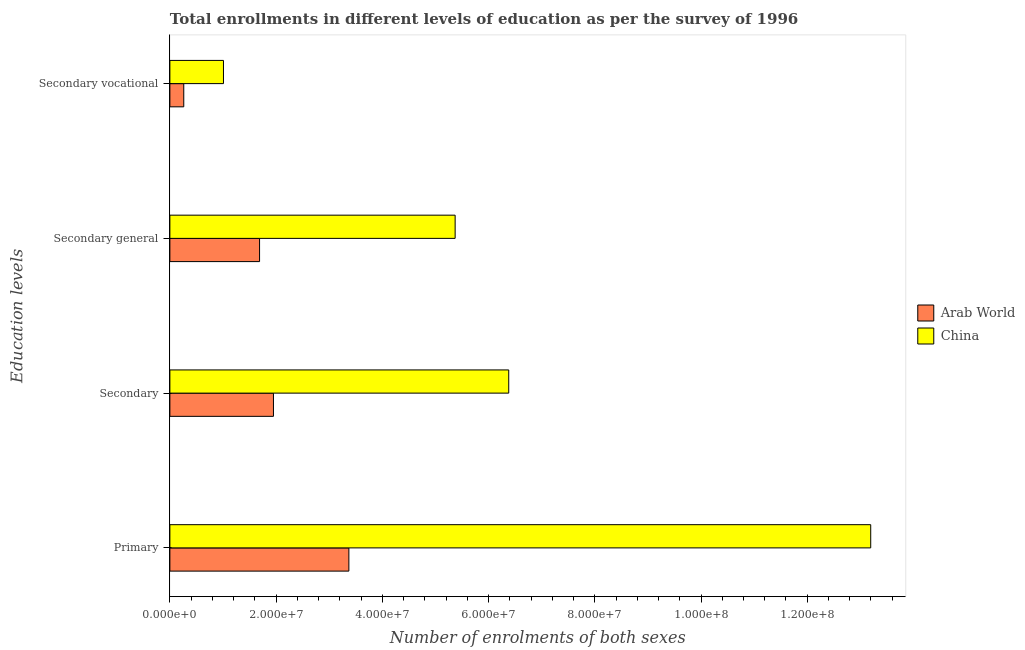Are the number of bars per tick equal to the number of legend labels?
Ensure brevity in your answer.  Yes. How many bars are there on the 4th tick from the bottom?
Your answer should be very brief. 2. What is the label of the 3rd group of bars from the top?
Your answer should be compact. Secondary. What is the number of enrolments in secondary general education in China?
Give a very brief answer. 5.37e+07. Across all countries, what is the maximum number of enrolments in primary education?
Provide a succinct answer. 1.32e+08. Across all countries, what is the minimum number of enrolments in primary education?
Give a very brief answer. 3.37e+07. In which country was the number of enrolments in secondary vocational education minimum?
Your response must be concise. Arab World. What is the total number of enrolments in secondary general education in the graph?
Your answer should be very brief. 7.06e+07. What is the difference between the number of enrolments in secondary general education in China and that in Arab World?
Offer a very short reply. 3.68e+07. What is the difference between the number of enrolments in primary education in China and the number of enrolments in secondary general education in Arab World?
Offer a very short reply. 1.15e+08. What is the average number of enrolments in secondary vocational education per country?
Make the answer very short. 6.35e+06. What is the difference between the number of enrolments in secondary general education and number of enrolments in primary education in Arab World?
Give a very brief answer. -1.68e+07. In how many countries, is the number of enrolments in secondary education greater than 32000000 ?
Your answer should be very brief. 1. What is the ratio of the number of enrolments in secondary vocational education in Arab World to that in China?
Give a very brief answer. 0.26. Is the number of enrolments in secondary education in China less than that in Arab World?
Offer a very short reply. No. What is the difference between the highest and the second highest number of enrolments in secondary vocational education?
Your answer should be very brief. 7.48e+06. What is the difference between the highest and the lowest number of enrolments in secondary general education?
Give a very brief answer. 3.68e+07. What does the 1st bar from the top in Secondary general represents?
Offer a terse response. China. Is it the case that in every country, the sum of the number of enrolments in primary education and number of enrolments in secondary education is greater than the number of enrolments in secondary general education?
Offer a very short reply. Yes. How many bars are there?
Provide a short and direct response. 8. How many countries are there in the graph?
Your response must be concise. 2. Does the graph contain grids?
Offer a very short reply. No. Where does the legend appear in the graph?
Provide a succinct answer. Center right. What is the title of the graph?
Your response must be concise. Total enrollments in different levels of education as per the survey of 1996. What is the label or title of the X-axis?
Keep it short and to the point. Number of enrolments of both sexes. What is the label or title of the Y-axis?
Give a very brief answer. Education levels. What is the Number of enrolments of both sexes of Arab World in Primary?
Provide a short and direct response. 3.37e+07. What is the Number of enrolments of both sexes of China in Primary?
Your answer should be compact. 1.32e+08. What is the Number of enrolments of both sexes in Arab World in Secondary?
Your response must be concise. 1.95e+07. What is the Number of enrolments of both sexes of China in Secondary?
Give a very brief answer. 6.38e+07. What is the Number of enrolments of both sexes in Arab World in Secondary general?
Provide a short and direct response. 1.69e+07. What is the Number of enrolments of both sexes of China in Secondary general?
Your answer should be very brief. 5.37e+07. What is the Number of enrolments of both sexes in Arab World in Secondary vocational?
Your response must be concise. 2.61e+06. What is the Number of enrolments of both sexes in China in Secondary vocational?
Keep it short and to the point. 1.01e+07. Across all Education levels, what is the maximum Number of enrolments of both sexes in Arab World?
Ensure brevity in your answer.  3.37e+07. Across all Education levels, what is the maximum Number of enrolments of both sexes of China?
Make the answer very short. 1.32e+08. Across all Education levels, what is the minimum Number of enrolments of both sexes of Arab World?
Your answer should be very brief. 2.61e+06. Across all Education levels, what is the minimum Number of enrolments of both sexes of China?
Keep it short and to the point. 1.01e+07. What is the total Number of enrolments of both sexes of Arab World in the graph?
Keep it short and to the point. 7.27e+07. What is the total Number of enrolments of both sexes in China in the graph?
Your response must be concise. 2.60e+08. What is the difference between the Number of enrolments of both sexes in Arab World in Primary and that in Secondary?
Give a very brief answer. 1.42e+07. What is the difference between the Number of enrolments of both sexes in China in Primary and that in Secondary?
Your answer should be compact. 6.82e+07. What is the difference between the Number of enrolments of both sexes in Arab World in Primary and that in Secondary general?
Offer a terse response. 1.68e+07. What is the difference between the Number of enrolments of both sexes of China in Primary and that in Secondary general?
Keep it short and to the point. 7.82e+07. What is the difference between the Number of enrolments of both sexes of Arab World in Primary and that in Secondary vocational?
Your response must be concise. 3.11e+07. What is the difference between the Number of enrolments of both sexes in China in Primary and that in Secondary vocational?
Your answer should be compact. 1.22e+08. What is the difference between the Number of enrolments of both sexes in Arab World in Secondary and that in Secondary general?
Your answer should be very brief. 2.61e+06. What is the difference between the Number of enrolments of both sexes in China in Secondary and that in Secondary general?
Give a very brief answer. 1.01e+07. What is the difference between the Number of enrolments of both sexes in Arab World in Secondary and that in Secondary vocational?
Your response must be concise. 1.69e+07. What is the difference between the Number of enrolments of both sexes of China in Secondary and that in Secondary vocational?
Your answer should be compact. 5.37e+07. What is the difference between the Number of enrolments of both sexes of Arab World in Secondary general and that in Secondary vocational?
Offer a very short reply. 1.43e+07. What is the difference between the Number of enrolments of both sexes in China in Secondary general and that in Secondary vocational?
Keep it short and to the point. 4.36e+07. What is the difference between the Number of enrolments of both sexes in Arab World in Primary and the Number of enrolments of both sexes in China in Secondary?
Provide a succinct answer. -3.01e+07. What is the difference between the Number of enrolments of both sexes of Arab World in Primary and the Number of enrolments of both sexes of China in Secondary general?
Provide a short and direct response. -2.00e+07. What is the difference between the Number of enrolments of both sexes in Arab World in Primary and the Number of enrolments of both sexes in China in Secondary vocational?
Your response must be concise. 2.36e+07. What is the difference between the Number of enrolments of both sexes in Arab World in Secondary and the Number of enrolments of both sexes in China in Secondary general?
Offer a very short reply. -3.42e+07. What is the difference between the Number of enrolments of both sexes of Arab World in Secondary and the Number of enrolments of both sexes of China in Secondary vocational?
Make the answer very short. 9.41e+06. What is the difference between the Number of enrolments of both sexes in Arab World in Secondary general and the Number of enrolments of both sexes in China in Secondary vocational?
Offer a very short reply. 6.80e+06. What is the average Number of enrolments of both sexes of Arab World per Education levels?
Provide a succinct answer. 1.82e+07. What is the average Number of enrolments of both sexes of China per Education levels?
Your answer should be very brief. 6.49e+07. What is the difference between the Number of enrolments of both sexes in Arab World and Number of enrolments of both sexes in China in Primary?
Your response must be concise. -9.82e+07. What is the difference between the Number of enrolments of both sexes of Arab World and Number of enrolments of both sexes of China in Secondary?
Your answer should be compact. -4.43e+07. What is the difference between the Number of enrolments of both sexes of Arab World and Number of enrolments of both sexes of China in Secondary general?
Offer a terse response. -3.68e+07. What is the difference between the Number of enrolments of both sexes of Arab World and Number of enrolments of both sexes of China in Secondary vocational?
Your answer should be very brief. -7.48e+06. What is the ratio of the Number of enrolments of both sexes of Arab World in Primary to that in Secondary?
Make the answer very short. 1.73. What is the ratio of the Number of enrolments of both sexes of China in Primary to that in Secondary?
Ensure brevity in your answer.  2.07. What is the ratio of the Number of enrolments of both sexes in Arab World in Primary to that in Secondary general?
Offer a very short reply. 2. What is the ratio of the Number of enrolments of both sexes in China in Primary to that in Secondary general?
Offer a very short reply. 2.46. What is the ratio of the Number of enrolments of both sexes in Arab World in Primary to that in Secondary vocational?
Offer a terse response. 12.89. What is the ratio of the Number of enrolments of both sexes of China in Primary to that in Secondary vocational?
Your answer should be very brief. 13.08. What is the ratio of the Number of enrolments of both sexes in Arab World in Secondary to that in Secondary general?
Offer a very short reply. 1.15. What is the ratio of the Number of enrolments of both sexes in China in Secondary to that in Secondary general?
Ensure brevity in your answer.  1.19. What is the ratio of the Number of enrolments of both sexes in Arab World in Secondary to that in Secondary vocational?
Your answer should be compact. 7.46. What is the ratio of the Number of enrolments of both sexes of China in Secondary to that in Secondary vocational?
Your answer should be compact. 6.32. What is the ratio of the Number of enrolments of both sexes in Arab World in Secondary general to that in Secondary vocational?
Provide a short and direct response. 6.46. What is the ratio of the Number of enrolments of both sexes in China in Secondary general to that in Secondary vocational?
Offer a terse response. 5.32. What is the difference between the highest and the second highest Number of enrolments of both sexes of Arab World?
Your answer should be very brief. 1.42e+07. What is the difference between the highest and the second highest Number of enrolments of both sexes of China?
Provide a succinct answer. 6.82e+07. What is the difference between the highest and the lowest Number of enrolments of both sexes in Arab World?
Your answer should be compact. 3.11e+07. What is the difference between the highest and the lowest Number of enrolments of both sexes in China?
Ensure brevity in your answer.  1.22e+08. 